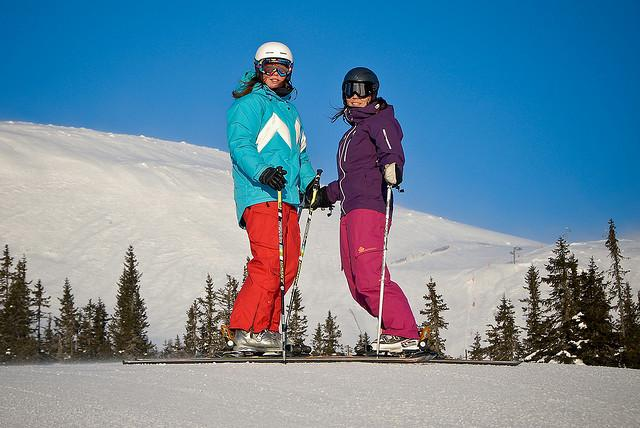What's the weather like for these skiers?

Choices:
A) clear
B) stormy
C) cloudy
D) rainy clear 